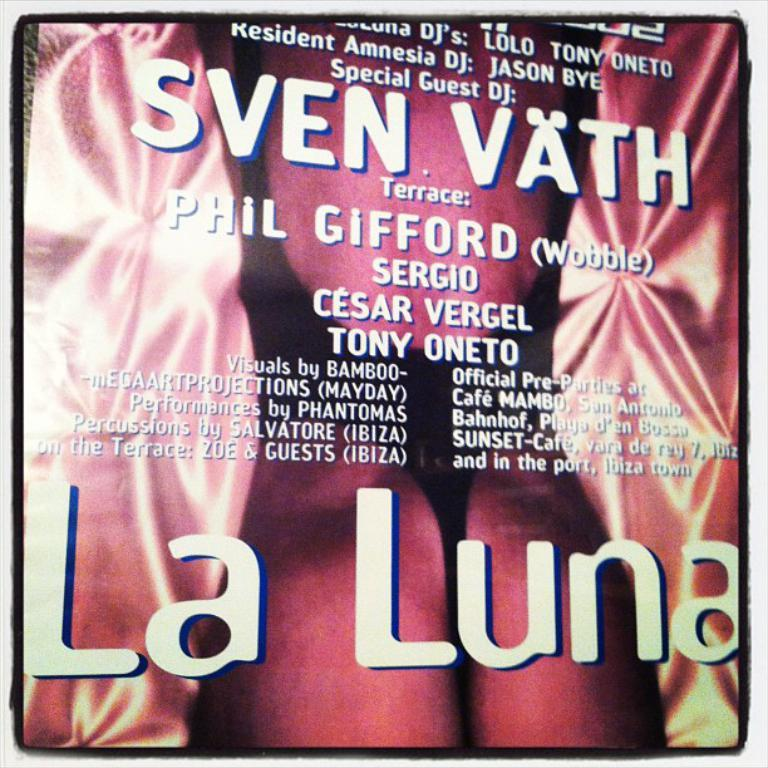<image>
Provide a brief description of the given image. A cover that says La Luna and Sven Vath. 